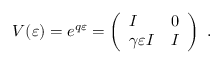<formula> <loc_0><loc_0><loc_500><loc_500>V ( \varepsilon ) = e ^ { q \varepsilon } = \left ( \begin{array} { l l } { I } & { 0 } \\ { \gamma \varepsilon I } & { I } \end{array} \right ) .</formula> 